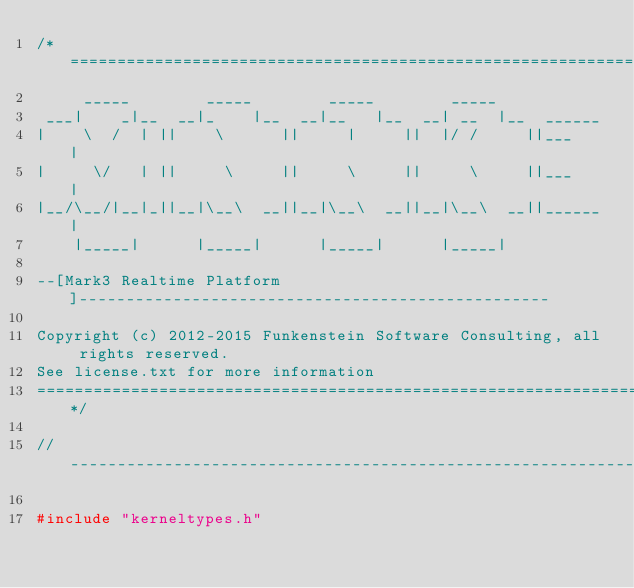Convert code to text. <code><loc_0><loc_0><loc_500><loc_500><_C_>/*===========================================================================
     _____        _____        _____        _____
 ___|    _|__  __|_    |__  __|__   |__  __| __  |__  ______
|    \  /  | ||    \      ||     |     ||  |/ /     ||___   |
|     \/   | ||     \     ||     \     ||     \     ||___   |
|__/\__/|__|_||__|\__\  __||__|\__\  __||__|\__\  __||______|
    |_____|      |_____|      |_____|      |_____|

--[Mark3 Realtime Platform]--------------------------------------------------

Copyright (c) 2012-2015 Funkenstein Software Consulting, all rights reserved.
See license.txt for more information
===========================================================================*/

//---------------------------------------------------------------------------

#include "kerneltypes.h"</code> 